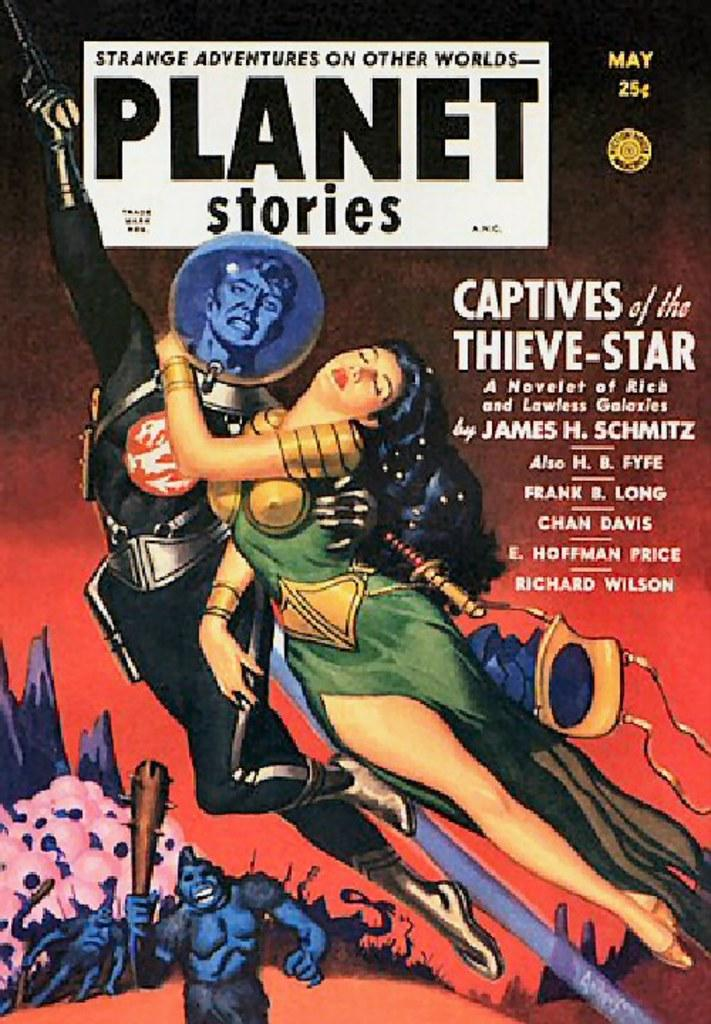<image>
Render a clear and concise summary of the photo. Strange adventrues on other wolds comic has a man rescuing a swimming woman. 